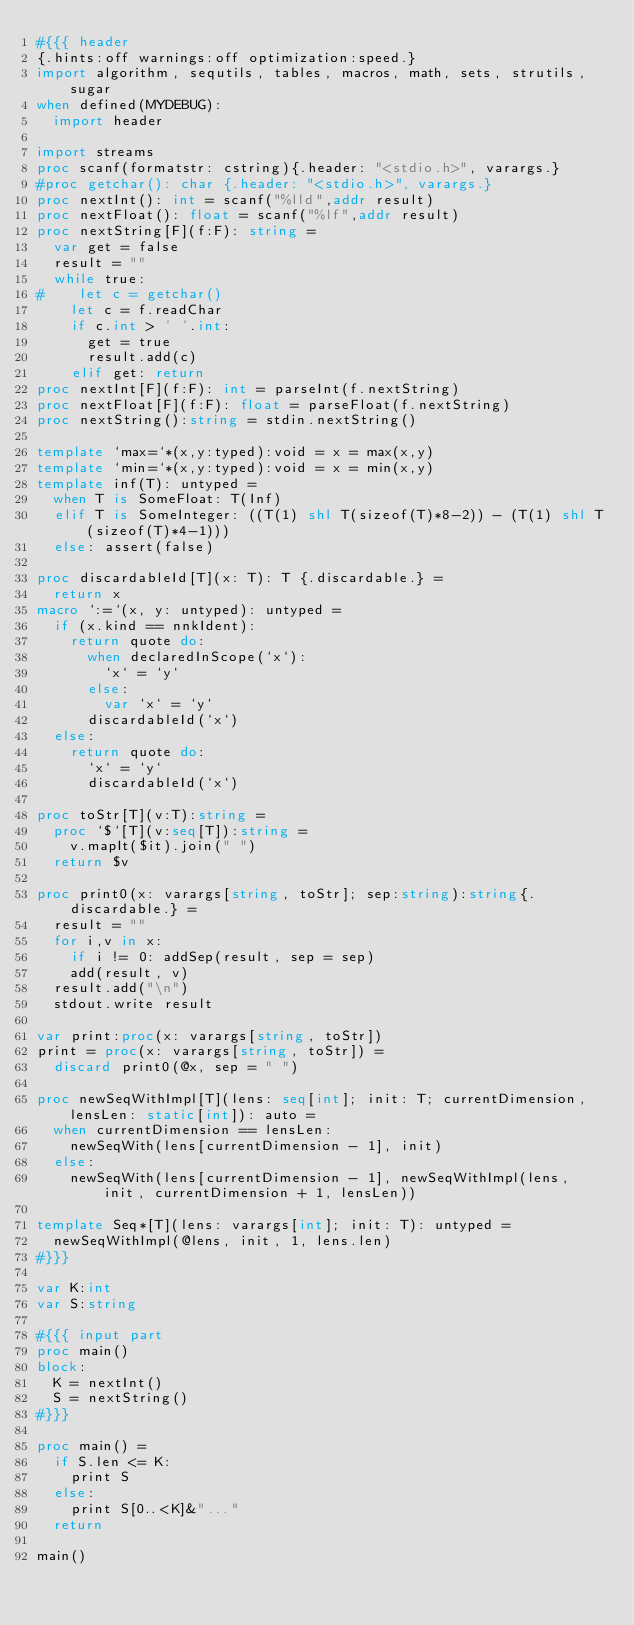<code> <loc_0><loc_0><loc_500><loc_500><_Nim_>#{{{ header
{.hints:off warnings:off optimization:speed.}
import algorithm, sequtils, tables, macros, math, sets, strutils, sugar
when defined(MYDEBUG):
  import header

import streams
proc scanf(formatstr: cstring){.header: "<stdio.h>", varargs.}
#proc getchar(): char {.header: "<stdio.h>", varargs.}
proc nextInt(): int = scanf("%lld",addr result)
proc nextFloat(): float = scanf("%lf",addr result)
proc nextString[F](f:F): string =
  var get = false
  result = ""
  while true:
#    let c = getchar()
    let c = f.readChar
    if c.int > ' '.int:
      get = true
      result.add(c)
    elif get: return
proc nextInt[F](f:F): int = parseInt(f.nextString)
proc nextFloat[F](f:F): float = parseFloat(f.nextString)
proc nextString():string = stdin.nextString()

template `max=`*(x,y:typed):void = x = max(x,y)
template `min=`*(x,y:typed):void = x = min(x,y)
template inf(T): untyped = 
  when T is SomeFloat: T(Inf)
  elif T is SomeInteger: ((T(1) shl T(sizeof(T)*8-2)) - (T(1) shl T(sizeof(T)*4-1)))
  else: assert(false)

proc discardableId[T](x: T): T {.discardable.} =
  return x
macro `:=`(x, y: untyped): untyped =
  if (x.kind == nnkIdent):
    return quote do:
      when declaredInScope(`x`):
        `x` = `y`
      else:
        var `x` = `y`
      discardableId(`x`)
  else:
    return quote do:
      `x` = `y`
      discardableId(`x`)

proc toStr[T](v:T):string =
  proc `$`[T](v:seq[T]):string =
    v.mapIt($it).join(" ")
  return $v

proc print0(x: varargs[string, toStr]; sep:string):string{.discardable.} =
  result = ""
  for i,v in x:
    if i != 0: addSep(result, sep = sep)
    add(result, v)
  result.add("\n")
  stdout.write result

var print:proc(x: varargs[string, toStr])
print = proc(x: varargs[string, toStr]) =
  discard print0(@x, sep = " ")

proc newSeqWithImpl[T](lens: seq[int]; init: T; currentDimension, lensLen: static[int]): auto =
  when currentDimension == lensLen:
    newSeqWith(lens[currentDimension - 1], init)
  else:
    newSeqWith(lens[currentDimension - 1], newSeqWithImpl(lens, init, currentDimension + 1, lensLen))

template Seq*[T](lens: varargs[int]; init: T): untyped =
  newSeqWithImpl(@lens, init, 1, lens.len)
#}}}

var K:int
var S:string

#{{{ input part
proc main()
block:
  K = nextInt()
  S = nextString()
#}}}

proc main() =
  if S.len <= K:
    print S
  else:
    print S[0..<K]&"..."
  return

main()
</code> 